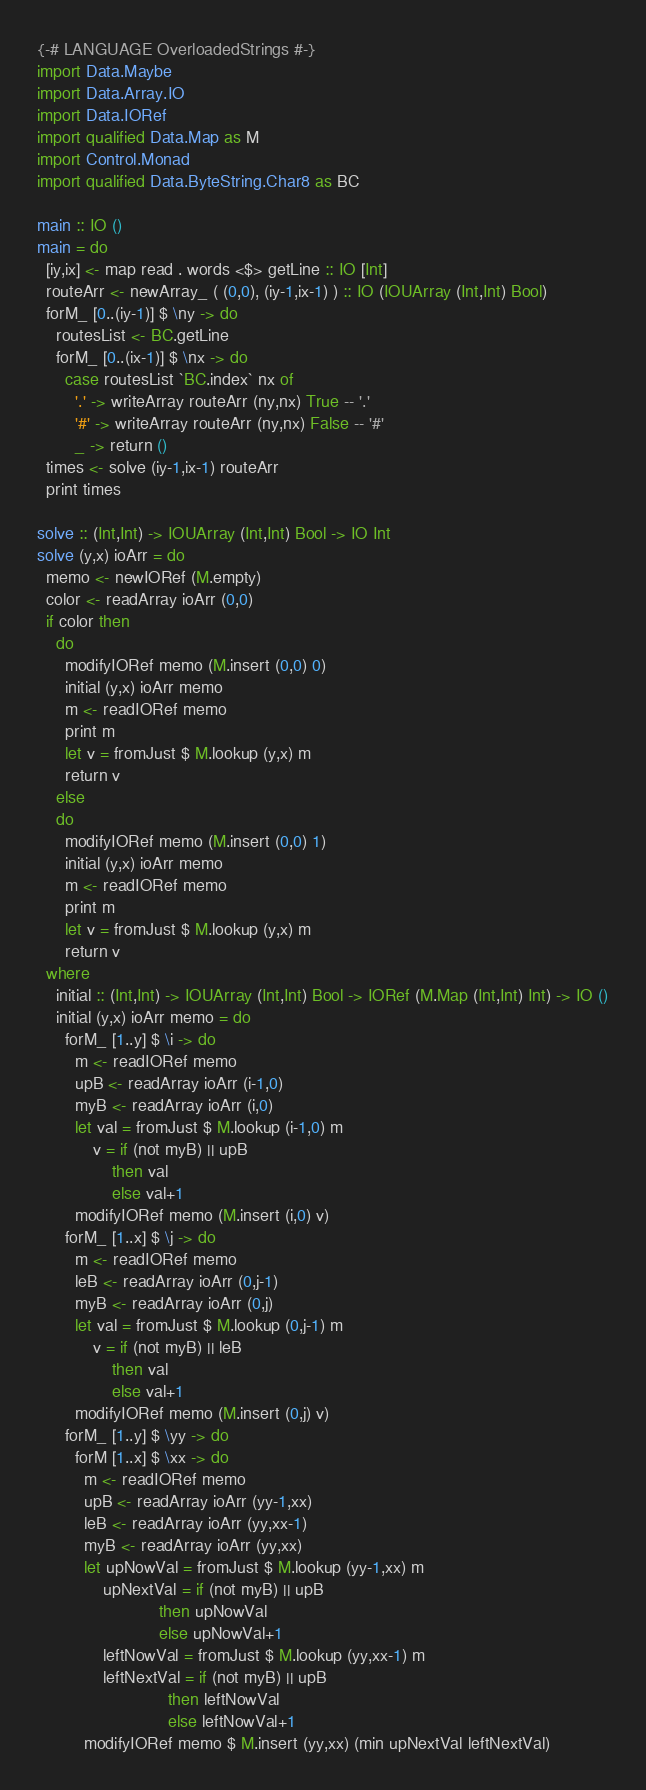<code> <loc_0><loc_0><loc_500><loc_500><_Haskell_>{-# LANGUAGE OverloadedStrings #-}
import Data.Maybe
import Data.Array.IO
import Data.IORef
import qualified Data.Map as M
import Control.Monad
import qualified Data.ByteString.Char8 as BC

main :: IO ()
main = do
  [iy,ix] <- map read . words <$> getLine :: IO [Int]
  routeArr <- newArray_ ( (0,0), (iy-1,ix-1) ) :: IO (IOUArray (Int,Int) Bool)
  forM_ [0..(iy-1)] $ \ny -> do
    routesList <- BC.getLine
    forM_ [0..(ix-1)] $ \nx -> do
      case routesList `BC.index` nx of
        '.' -> writeArray routeArr (ny,nx) True -- '.'
        '#' -> writeArray routeArr (ny,nx) False -- '#'
        _ -> return ()
  times <- solve (iy-1,ix-1) routeArr
  print times

solve :: (Int,Int) -> IOUArray (Int,Int) Bool -> IO Int
solve (y,x) ioArr = do
  memo <- newIORef (M.empty)
  color <- readArray ioArr (0,0)
  if color then
    do
      modifyIORef memo (M.insert (0,0) 0)
      initial (y,x) ioArr memo
      m <- readIORef memo
      print m
      let v = fromJust $ M.lookup (y,x) m
      return v
    else
    do
      modifyIORef memo (M.insert (0,0) 1)
      initial (y,x) ioArr memo
      m <- readIORef memo
      print m
      let v = fromJust $ M.lookup (y,x) m
      return v
  where
    initial :: (Int,Int) -> IOUArray (Int,Int) Bool -> IORef (M.Map (Int,Int) Int) -> IO ()
    initial (y,x) ioArr memo = do
      forM_ [1..y] $ \i -> do
        m <- readIORef memo
        upB <- readArray ioArr (i-1,0)
        myB <- readArray ioArr (i,0)
        let val = fromJust $ M.lookup (i-1,0) m
            v = if (not myB) || upB
                then val
                else val+1
        modifyIORef memo (M.insert (i,0) v)
      forM_ [1..x] $ \j -> do
        m <- readIORef memo
        leB <- readArray ioArr (0,j-1)
        myB <- readArray ioArr (0,j)
        let val = fromJust $ M.lookup (0,j-1) m
            v = if (not myB) || leB
                then val
                else val+1
        modifyIORef memo (M.insert (0,j) v)
      forM_ [1..y] $ \yy -> do
        forM [1..x] $ \xx -> do
          m <- readIORef memo
          upB <- readArray ioArr (yy-1,xx)
          leB <- readArray ioArr (yy,xx-1)
          myB <- readArray ioArr (yy,xx)
          let upNowVal = fromJust $ M.lookup (yy-1,xx) m
              upNextVal = if (not myB) || upB
                          then upNowVal
                          else upNowVal+1
              leftNowVal = fromJust $ M.lookup (yy,xx-1) m
              leftNextVal = if (not myB) || upB
                            then leftNowVal
                            else leftNowVal+1
          modifyIORef memo $ M.insert (yy,xx) (min upNextVal leftNextVal)
</code> 